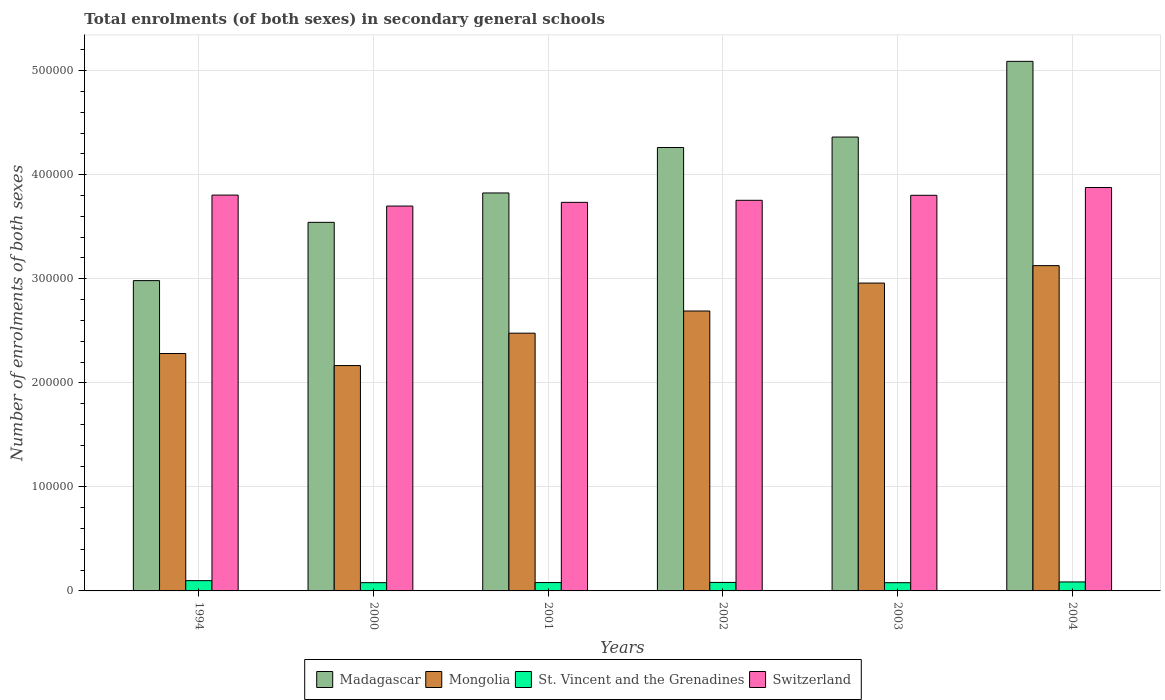Are the number of bars per tick equal to the number of legend labels?
Give a very brief answer. Yes. How many bars are there on the 4th tick from the left?
Offer a very short reply. 4. What is the label of the 1st group of bars from the left?
Keep it short and to the point. 1994. What is the number of enrolments in secondary schools in Mongolia in 1994?
Provide a succinct answer. 2.28e+05. Across all years, what is the maximum number of enrolments in secondary schools in Mongolia?
Offer a very short reply. 3.13e+05. Across all years, what is the minimum number of enrolments in secondary schools in Switzerland?
Provide a succinct answer. 3.70e+05. In which year was the number of enrolments in secondary schools in Mongolia minimum?
Your answer should be compact. 2000. What is the total number of enrolments in secondary schools in St. Vincent and the Grenadines in the graph?
Provide a short and direct response. 5.05e+04. What is the difference between the number of enrolments in secondary schools in Switzerland in 1994 and that in 2000?
Keep it short and to the point. 1.05e+04. What is the difference between the number of enrolments in secondary schools in Switzerland in 2001 and the number of enrolments in secondary schools in St. Vincent and the Grenadines in 2004?
Ensure brevity in your answer.  3.65e+05. What is the average number of enrolments in secondary schools in Madagascar per year?
Make the answer very short. 4.01e+05. In the year 2000, what is the difference between the number of enrolments in secondary schools in Mongolia and number of enrolments in secondary schools in Switzerland?
Ensure brevity in your answer.  -1.53e+05. What is the ratio of the number of enrolments in secondary schools in Madagascar in 1994 to that in 2000?
Provide a succinct answer. 0.84. Is the number of enrolments in secondary schools in Madagascar in 2000 less than that in 2004?
Make the answer very short. Yes. Is the difference between the number of enrolments in secondary schools in Mongolia in 1994 and 2003 greater than the difference between the number of enrolments in secondary schools in Switzerland in 1994 and 2003?
Your answer should be very brief. No. What is the difference between the highest and the second highest number of enrolments in secondary schools in St. Vincent and the Grenadines?
Give a very brief answer. 1241. What is the difference between the highest and the lowest number of enrolments in secondary schools in St. Vincent and the Grenadines?
Your response must be concise. 1961. What does the 4th bar from the left in 2002 represents?
Your answer should be compact. Switzerland. What does the 2nd bar from the right in 1994 represents?
Ensure brevity in your answer.  St. Vincent and the Grenadines. Is it the case that in every year, the sum of the number of enrolments in secondary schools in Switzerland and number of enrolments in secondary schools in Madagascar is greater than the number of enrolments in secondary schools in Mongolia?
Your response must be concise. Yes. How many bars are there?
Make the answer very short. 24. What is the title of the graph?
Give a very brief answer. Total enrolments (of both sexes) in secondary general schools. What is the label or title of the Y-axis?
Ensure brevity in your answer.  Number of enrolments of both sexes. What is the Number of enrolments of both sexes of Madagascar in 1994?
Make the answer very short. 2.98e+05. What is the Number of enrolments of both sexes in Mongolia in 1994?
Provide a succinct answer. 2.28e+05. What is the Number of enrolments of both sexes in St. Vincent and the Grenadines in 1994?
Ensure brevity in your answer.  9870. What is the Number of enrolments of both sexes in Switzerland in 1994?
Your answer should be compact. 3.80e+05. What is the Number of enrolments of both sexes in Madagascar in 2000?
Keep it short and to the point. 3.54e+05. What is the Number of enrolments of both sexes in Mongolia in 2000?
Offer a very short reply. 2.17e+05. What is the Number of enrolments of both sexes of St. Vincent and the Grenadines in 2000?
Give a very brief answer. 7939. What is the Number of enrolments of both sexes in Switzerland in 2000?
Your response must be concise. 3.70e+05. What is the Number of enrolments of both sexes of Madagascar in 2001?
Provide a short and direct response. 3.82e+05. What is the Number of enrolments of both sexes in Mongolia in 2001?
Keep it short and to the point. 2.48e+05. What is the Number of enrolments of both sexes of St. Vincent and the Grenadines in 2001?
Give a very brief answer. 8045. What is the Number of enrolments of both sexes of Switzerland in 2001?
Offer a terse response. 3.73e+05. What is the Number of enrolments of both sexes in Madagascar in 2002?
Keep it short and to the point. 4.26e+05. What is the Number of enrolments of both sexes of Mongolia in 2002?
Your response must be concise. 2.69e+05. What is the Number of enrolments of both sexes of St. Vincent and the Grenadines in 2002?
Make the answer very short. 8157. What is the Number of enrolments of both sexes of Switzerland in 2002?
Offer a very short reply. 3.75e+05. What is the Number of enrolments of both sexes in Madagascar in 2003?
Provide a short and direct response. 4.36e+05. What is the Number of enrolments of both sexes of Mongolia in 2003?
Provide a short and direct response. 2.96e+05. What is the Number of enrolments of both sexes of St. Vincent and the Grenadines in 2003?
Your response must be concise. 7909. What is the Number of enrolments of both sexes of Switzerland in 2003?
Keep it short and to the point. 3.80e+05. What is the Number of enrolments of both sexes in Madagascar in 2004?
Ensure brevity in your answer.  5.09e+05. What is the Number of enrolments of both sexes of Mongolia in 2004?
Provide a succinct answer. 3.13e+05. What is the Number of enrolments of both sexes of St. Vincent and the Grenadines in 2004?
Provide a succinct answer. 8629. What is the Number of enrolments of both sexes of Switzerland in 2004?
Offer a very short reply. 3.88e+05. Across all years, what is the maximum Number of enrolments of both sexes of Madagascar?
Ensure brevity in your answer.  5.09e+05. Across all years, what is the maximum Number of enrolments of both sexes in Mongolia?
Offer a terse response. 3.13e+05. Across all years, what is the maximum Number of enrolments of both sexes in St. Vincent and the Grenadines?
Offer a terse response. 9870. Across all years, what is the maximum Number of enrolments of both sexes in Switzerland?
Your answer should be very brief. 3.88e+05. Across all years, what is the minimum Number of enrolments of both sexes in Madagascar?
Make the answer very short. 2.98e+05. Across all years, what is the minimum Number of enrolments of both sexes in Mongolia?
Offer a very short reply. 2.17e+05. Across all years, what is the minimum Number of enrolments of both sexes of St. Vincent and the Grenadines?
Keep it short and to the point. 7909. Across all years, what is the minimum Number of enrolments of both sexes of Switzerland?
Your response must be concise. 3.70e+05. What is the total Number of enrolments of both sexes of Madagascar in the graph?
Provide a short and direct response. 2.41e+06. What is the total Number of enrolments of both sexes in Mongolia in the graph?
Make the answer very short. 1.57e+06. What is the total Number of enrolments of both sexes of St. Vincent and the Grenadines in the graph?
Your answer should be compact. 5.05e+04. What is the total Number of enrolments of both sexes in Switzerland in the graph?
Offer a very short reply. 2.27e+06. What is the difference between the Number of enrolments of both sexes in Madagascar in 1994 and that in 2000?
Offer a terse response. -5.60e+04. What is the difference between the Number of enrolments of both sexes of Mongolia in 1994 and that in 2000?
Your answer should be compact. 1.16e+04. What is the difference between the Number of enrolments of both sexes in St. Vincent and the Grenadines in 1994 and that in 2000?
Make the answer very short. 1931. What is the difference between the Number of enrolments of both sexes in Switzerland in 1994 and that in 2000?
Ensure brevity in your answer.  1.05e+04. What is the difference between the Number of enrolments of both sexes of Madagascar in 1994 and that in 2001?
Keep it short and to the point. -8.42e+04. What is the difference between the Number of enrolments of both sexes of Mongolia in 1994 and that in 2001?
Offer a terse response. -1.95e+04. What is the difference between the Number of enrolments of both sexes of St. Vincent and the Grenadines in 1994 and that in 2001?
Make the answer very short. 1825. What is the difference between the Number of enrolments of both sexes in Switzerland in 1994 and that in 2001?
Provide a short and direct response. 6978. What is the difference between the Number of enrolments of both sexes of Madagascar in 1994 and that in 2002?
Provide a short and direct response. -1.28e+05. What is the difference between the Number of enrolments of both sexes of Mongolia in 1994 and that in 2002?
Ensure brevity in your answer.  -4.09e+04. What is the difference between the Number of enrolments of both sexes of St. Vincent and the Grenadines in 1994 and that in 2002?
Keep it short and to the point. 1713. What is the difference between the Number of enrolments of both sexes of Switzerland in 1994 and that in 2002?
Your answer should be very brief. 5016. What is the difference between the Number of enrolments of both sexes in Madagascar in 1994 and that in 2003?
Provide a short and direct response. -1.38e+05. What is the difference between the Number of enrolments of both sexes of Mongolia in 1994 and that in 2003?
Provide a short and direct response. -6.77e+04. What is the difference between the Number of enrolments of both sexes of St. Vincent and the Grenadines in 1994 and that in 2003?
Offer a terse response. 1961. What is the difference between the Number of enrolments of both sexes in Switzerland in 1994 and that in 2003?
Offer a very short reply. 216. What is the difference between the Number of enrolments of both sexes of Madagascar in 1994 and that in 2004?
Make the answer very short. -2.11e+05. What is the difference between the Number of enrolments of both sexes in Mongolia in 1994 and that in 2004?
Offer a very short reply. -8.45e+04. What is the difference between the Number of enrolments of both sexes of St. Vincent and the Grenadines in 1994 and that in 2004?
Keep it short and to the point. 1241. What is the difference between the Number of enrolments of both sexes in Switzerland in 1994 and that in 2004?
Your answer should be compact. -7283. What is the difference between the Number of enrolments of both sexes of Madagascar in 2000 and that in 2001?
Your answer should be very brief. -2.82e+04. What is the difference between the Number of enrolments of both sexes in Mongolia in 2000 and that in 2001?
Make the answer very short. -3.11e+04. What is the difference between the Number of enrolments of both sexes in St. Vincent and the Grenadines in 2000 and that in 2001?
Provide a short and direct response. -106. What is the difference between the Number of enrolments of both sexes of Switzerland in 2000 and that in 2001?
Ensure brevity in your answer.  -3567. What is the difference between the Number of enrolments of both sexes of Madagascar in 2000 and that in 2002?
Offer a very short reply. -7.19e+04. What is the difference between the Number of enrolments of both sexes in Mongolia in 2000 and that in 2002?
Keep it short and to the point. -5.24e+04. What is the difference between the Number of enrolments of both sexes of St. Vincent and the Grenadines in 2000 and that in 2002?
Make the answer very short. -218. What is the difference between the Number of enrolments of both sexes of Switzerland in 2000 and that in 2002?
Provide a succinct answer. -5529. What is the difference between the Number of enrolments of both sexes of Madagascar in 2000 and that in 2003?
Keep it short and to the point. -8.20e+04. What is the difference between the Number of enrolments of both sexes of Mongolia in 2000 and that in 2003?
Your response must be concise. -7.93e+04. What is the difference between the Number of enrolments of both sexes of St. Vincent and the Grenadines in 2000 and that in 2003?
Keep it short and to the point. 30. What is the difference between the Number of enrolments of both sexes in Switzerland in 2000 and that in 2003?
Your answer should be very brief. -1.03e+04. What is the difference between the Number of enrolments of both sexes of Madagascar in 2000 and that in 2004?
Provide a short and direct response. -1.55e+05. What is the difference between the Number of enrolments of both sexes in Mongolia in 2000 and that in 2004?
Keep it short and to the point. -9.60e+04. What is the difference between the Number of enrolments of both sexes of St. Vincent and the Grenadines in 2000 and that in 2004?
Ensure brevity in your answer.  -690. What is the difference between the Number of enrolments of both sexes of Switzerland in 2000 and that in 2004?
Make the answer very short. -1.78e+04. What is the difference between the Number of enrolments of both sexes of Madagascar in 2001 and that in 2002?
Your answer should be compact. -4.37e+04. What is the difference between the Number of enrolments of both sexes of Mongolia in 2001 and that in 2002?
Your answer should be very brief. -2.13e+04. What is the difference between the Number of enrolments of both sexes in St. Vincent and the Grenadines in 2001 and that in 2002?
Give a very brief answer. -112. What is the difference between the Number of enrolments of both sexes of Switzerland in 2001 and that in 2002?
Offer a very short reply. -1962. What is the difference between the Number of enrolments of both sexes in Madagascar in 2001 and that in 2003?
Your response must be concise. -5.37e+04. What is the difference between the Number of enrolments of both sexes in Mongolia in 2001 and that in 2003?
Your answer should be very brief. -4.82e+04. What is the difference between the Number of enrolments of both sexes in St. Vincent and the Grenadines in 2001 and that in 2003?
Offer a terse response. 136. What is the difference between the Number of enrolments of both sexes in Switzerland in 2001 and that in 2003?
Your answer should be very brief. -6762. What is the difference between the Number of enrolments of both sexes of Madagascar in 2001 and that in 2004?
Your answer should be compact. -1.26e+05. What is the difference between the Number of enrolments of both sexes in Mongolia in 2001 and that in 2004?
Offer a very short reply. -6.49e+04. What is the difference between the Number of enrolments of both sexes in St. Vincent and the Grenadines in 2001 and that in 2004?
Ensure brevity in your answer.  -584. What is the difference between the Number of enrolments of both sexes of Switzerland in 2001 and that in 2004?
Your answer should be very brief. -1.43e+04. What is the difference between the Number of enrolments of both sexes of Madagascar in 2002 and that in 2003?
Your answer should be very brief. -1.00e+04. What is the difference between the Number of enrolments of both sexes in Mongolia in 2002 and that in 2003?
Give a very brief answer. -2.68e+04. What is the difference between the Number of enrolments of both sexes of St. Vincent and the Grenadines in 2002 and that in 2003?
Offer a very short reply. 248. What is the difference between the Number of enrolments of both sexes of Switzerland in 2002 and that in 2003?
Offer a terse response. -4800. What is the difference between the Number of enrolments of both sexes of Madagascar in 2002 and that in 2004?
Your response must be concise. -8.28e+04. What is the difference between the Number of enrolments of both sexes of Mongolia in 2002 and that in 2004?
Provide a short and direct response. -4.36e+04. What is the difference between the Number of enrolments of both sexes of St. Vincent and the Grenadines in 2002 and that in 2004?
Your answer should be very brief. -472. What is the difference between the Number of enrolments of both sexes of Switzerland in 2002 and that in 2004?
Provide a succinct answer. -1.23e+04. What is the difference between the Number of enrolments of both sexes of Madagascar in 2003 and that in 2004?
Your answer should be compact. -7.28e+04. What is the difference between the Number of enrolments of both sexes of Mongolia in 2003 and that in 2004?
Offer a terse response. -1.68e+04. What is the difference between the Number of enrolments of both sexes of St. Vincent and the Grenadines in 2003 and that in 2004?
Offer a terse response. -720. What is the difference between the Number of enrolments of both sexes of Switzerland in 2003 and that in 2004?
Offer a very short reply. -7499. What is the difference between the Number of enrolments of both sexes of Madagascar in 1994 and the Number of enrolments of both sexes of Mongolia in 2000?
Your response must be concise. 8.16e+04. What is the difference between the Number of enrolments of both sexes of Madagascar in 1994 and the Number of enrolments of both sexes of St. Vincent and the Grenadines in 2000?
Offer a terse response. 2.90e+05. What is the difference between the Number of enrolments of both sexes in Madagascar in 1994 and the Number of enrolments of both sexes in Switzerland in 2000?
Ensure brevity in your answer.  -7.17e+04. What is the difference between the Number of enrolments of both sexes of Mongolia in 1994 and the Number of enrolments of both sexes of St. Vincent and the Grenadines in 2000?
Your answer should be compact. 2.20e+05. What is the difference between the Number of enrolments of both sexes in Mongolia in 1994 and the Number of enrolments of both sexes in Switzerland in 2000?
Provide a succinct answer. -1.42e+05. What is the difference between the Number of enrolments of both sexes in St. Vincent and the Grenadines in 1994 and the Number of enrolments of both sexes in Switzerland in 2000?
Offer a very short reply. -3.60e+05. What is the difference between the Number of enrolments of both sexes in Madagascar in 1994 and the Number of enrolments of both sexes in Mongolia in 2001?
Your response must be concise. 5.05e+04. What is the difference between the Number of enrolments of both sexes of Madagascar in 1994 and the Number of enrolments of both sexes of St. Vincent and the Grenadines in 2001?
Keep it short and to the point. 2.90e+05. What is the difference between the Number of enrolments of both sexes in Madagascar in 1994 and the Number of enrolments of both sexes in Switzerland in 2001?
Offer a very short reply. -7.52e+04. What is the difference between the Number of enrolments of both sexes of Mongolia in 1994 and the Number of enrolments of both sexes of St. Vincent and the Grenadines in 2001?
Provide a short and direct response. 2.20e+05. What is the difference between the Number of enrolments of both sexes in Mongolia in 1994 and the Number of enrolments of both sexes in Switzerland in 2001?
Offer a terse response. -1.45e+05. What is the difference between the Number of enrolments of both sexes in St. Vincent and the Grenadines in 1994 and the Number of enrolments of both sexes in Switzerland in 2001?
Give a very brief answer. -3.64e+05. What is the difference between the Number of enrolments of both sexes in Madagascar in 1994 and the Number of enrolments of both sexes in Mongolia in 2002?
Give a very brief answer. 2.92e+04. What is the difference between the Number of enrolments of both sexes of Madagascar in 1994 and the Number of enrolments of both sexes of St. Vincent and the Grenadines in 2002?
Provide a succinct answer. 2.90e+05. What is the difference between the Number of enrolments of both sexes of Madagascar in 1994 and the Number of enrolments of both sexes of Switzerland in 2002?
Make the answer very short. -7.72e+04. What is the difference between the Number of enrolments of both sexes in Mongolia in 1994 and the Number of enrolments of both sexes in St. Vincent and the Grenadines in 2002?
Your response must be concise. 2.20e+05. What is the difference between the Number of enrolments of both sexes in Mongolia in 1994 and the Number of enrolments of both sexes in Switzerland in 2002?
Give a very brief answer. -1.47e+05. What is the difference between the Number of enrolments of both sexes of St. Vincent and the Grenadines in 1994 and the Number of enrolments of both sexes of Switzerland in 2002?
Your answer should be very brief. -3.66e+05. What is the difference between the Number of enrolments of both sexes in Madagascar in 1994 and the Number of enrolments of both sexes in Mongolia in 2003?
Your answer should be very brief. 2367. What is the difference between the Number of enrolments of both sexes in Madagascar in 1994 and the Number of enrolments of both sexes in St. Vincent and the Grenadines in 2003?
Offer a terse response. 2.90e+05. What is the difference between the Number of enrolments of both sexes in Madagascar in 1994 and the Number of enrolments of both sexes in Switzerland in 2003?
Give a very brief answer. -8.20e+04. What is the difference between the Number of enrolments of both sexes in Mongolia in 1994 and the Number of enrolments of both sexes in St. Vincent and the Grenadines in 2003?
Your response must be concise. 2.20e+05. What is the difference between the Number of enrolments of both sexes in Mongolia in 1994 and the Number of enrolments of both sexes in Switzerland in 2003?
Offer a terse response. -1.52e+05. What is the difference between the Number of enrolments of both sexes of St. Vincent and the Grenadines in 1994 and the Number of enrolments of both sexes of Switzerland in 2003?
Provide a short and direct response. -3.70e+05. What is the difference between the Number of enrolments of both sexes in Madagascar in 1994 and the Number of enrolments of both sexes in Mongolia in 2004?
Make the answer very short. -1.44e+04. What is the difference between the Number of enrolments of both sexes in Madagascar in 1994 and the Number of enrolments of both sexes in St. Vincent and the Grenadines in 2004?
Offer a very short reply. 2.90e+05. What is the difference between the Number of enrolments of both sexes in Madagascar in 1994 and the Number of enrolments of both sexes in Switzerland in 2004?
Your answer should be very brief. -8.95e+04. What is the difference between the Number of enrolments of both sexes of Mongolia in 1994 and the Number of enrolments of both sexes of St. Vincent and the Grenadines in 2004?
Make the answer very short. 2.20e+05. What is the difference between the Number of enrolments of both sexes in Mongolia in 1994 and the Number of enrolments of both sexes in Switzerland in 2004?
Make the answer very short. -1.60e+05. What is the difference between the Number of enrolments of both sexes of St. Vincent and the Grenadines in 1994 and the Number of enrolments of both sexes of Switzerland in 2004?
Offer a very short reply. -3.78e+05. What is the difference between the Number of enrolments of both sexes of Madagascar in 2000 and the Number of enrolments of both sexes of Mongolia in 2001?
Give a very brief answer. 1.07e+05. What is the difference between the Number of enrolments of both sexes of Madagascar in 2000 and the Number of enrolments of both sexes of St. Vincent and the Grenadines in 2001?
Offer a terse response. 3.46e+05. What is the difference between the Number of enrolments of both sexes in Madagascar in 2000 and the Number of enrolments of both sexes in Switzerland in 2001?
Offer a very short reply. -1.92e+04. What is the difference between the Number of enrolments of both sexes in Mongolia in 2000 and the Number of enrolments of both sexes in St. Vincent and the Grenadines in 2001?
Provide a succinct answer. 2.09e+05. What is the difference between the Number of enrolments of both sexes in Mongolia in 2000 and the Number of enrolments of both sexes in Switzerland in 2001?
Provide a succinct answer. -1.57e+05. What is the difference between the Number of enrolments of both sexes of St. Vincent and the Grenadines in 2000 and the Number of enrolments of both sexes of Switzerland in 2001?
Keep it short and to the point. -3.66e+05. What is the difference between the Number of enrolments of both sexes of Madagascar in 2000 and the Number of enrolments of both sexes of Mongolia in 2002?
Keep it short and to the point. 8.52e+04. What is the difference between the Number of enrolments of both sexes of Madagascar in 2000 and the Number of enrolments of both sexes of St. Vincent and the Grenadines in 2002?
Your answer should be very brief. 3.46e+05. What is the difference between the Number of enrolments of both sexes in Madagascar in 2000 and the Number of enrolments of both sexes in Switzerland in 2002?
Provide a short and direct response. -2.12e+04. What is the difference between the Number of enrolments of both sexes in Mongolia in 2000 and the Number of enrolments of both sexes in St. Vincent and the Grenadines in 2002?
Your answer should be compact. 2.08e+05. What is the difference between the Number of enrolments of both sexes in Mongolia in 2000 and the Number of enrolments of both sexes in Switzerland in 2002?
Offer a very short reply. -1.59e+05. What is the difference between the Number of enrolments of both sexes in St. Vincent and the Grenadines in 2000 and the Number of enrolments of both sexes in Switzerland in 2002?
Offer a very short reply. -3.67e+05. What is the difference between the Number of enrolments of both sexes of Madagascar in 2000 and the Number of enrolments of both sexes of Mongolia in 2003?
Your answer should be compact. 5.84e+04. What is the difference between the Number of enrolments of both sexes in Madagascar in 2000 and the Number of enrolments of both sexes in St. Vincent and the Grenadines in 2003?
Your response must be concise. 3.46e+05. What is the difference between the Number of enrolments of both sexes of Madagascar in 2000 and the Number of enrolments of both sexes of Switzerland in 2003?
Give a very brief answer. -2.60e+04. What is the difference between the Number of enrolments of both sexes in Mongolia in 2000 and the Number of enrolments of both sexes in St. Vincent and the Grenadines in 2003?
Your answer should be very brief. 2.09e+05. What is the difference between the Number of enrolments of both sexes of Mongolia in 2000 and the Number of enrolments of both sexes of Switzerland in 2003?
Your answer should be very brief. -1.64e+05. What is the difference between the Number of enrolments of both sexes of St. Vincent and the Grenadines in 2000 and the Number of enrolments of both sexes of Switzerland in 2003?
Give a very brief answer. -3.72e+05. What is the difference between the Number of enrolments of both sexes in Madagascar in 2000 and the Number of enrolments of both sexes in Mongolia in 2004?
Your response must be concise. 4.16e+04. What is the difference between the Number of enrolments of both sexes of Madagascar in 2000 and the Number of enrolments of both sexes of St. Vincent and the Grenadines in 2004?
Your answer should be very brief. 3.46e+05. What is the difference between the Number of enrolments of both sexes in Madagascar in 2000 and the Number of enrolments of both sexes in Switzerland in 2004?
Your answer should be compact. -3.35e+04. What is the difference between the Number of enrolments of both sexes in Mongolia in 2000 and the Number of enrolments of both sexes in St. Vincent and the Grenadines in 2004?
Keep it short and to the point. 2.08e+05. What is the difference between the Number of enrolments of both sexes in Mongolia in 2000 and the Number of enrolments of both sexes in Switzerland in 2004?
Your response must be concise. -1.71e+05. What is the difference between the Number of enrolments of both sexes in St. Vincent and the Grenadines in 2000 and the Number of enrolments of both sexes in Switzerland in 2004?
Your answer should be compact. -3.80e+05. What is the difference between the Number of enrolments of both sexes of Madagascar in 2001 and the Number of enrolments of both sexes of Mongolia in 2002?
Ensure brevity in your answer.  1.13e+05. What is the difference between the Number of enrolments of both sexes of Madagascar in 2001 and the Number of enrolments of both sexes of St. Vincent and the Grenadines in 2002?
Give a very brief answer. 3.74e+05. What is the difference between the Number of enrolments of both sexes in Madagascar in 2001 and the Number of enrolments of both sexes in Switzerland in 2002?
Your response must be concise. 7050. What is the difference between the Number of enrolments of both sexes of Mongolia in 2001 and the Number of enrolments of both sexes of St. Vincent and the Grenadines in 2002?
Provide a succinct answer. 2.40e+05. What is the difference between the Number of enrolments of both sexes in Mongolia in 2001 and the Number of enrolments of both sexes in Switzerland in 2002?
Provide a succinct answer. -1.28e+05. What is the difference between the Number of enrolments of both sexes in St. Vincent and the Grenadines in 2001 and the Number of enrolments of both sexes in Switzerland in 2002?
Keep it short and to the point. -3.67e+05. What is the difference between the Number of enrolments of both sexes of Madagascar in 2001 and the Number of enrolments of both sexes of Mongolia in 2003?
Your response must be concise. 8.66e+04. What is the difference between the Number of enrolments of both sexes of Madagascar in 2001 and the Number of enrolments of both sexes of St. Vincent and the Grenadines in 2003?
Offer a very short reply. 3.75e+05. What is the difference between the Number of enrolments of both sexes of Madagascar in 2001 and the Number of enrolments of both sexes of Switzerland in 2003?
Your response must be concise. 2250. What is the difference between the Number of enrolments of both sexes of Mongolia in 2001 and the Number of enrolments of both sexes of St. Vincent and the Grenadines in 2003?
Provide a short and direct response. 2.40e+05. What is the difference between the Number of enrolments of both sexes in Mongolia in 2001 and the Number of enrolments of both sexes in Switzerland in 2003?
Make the answer very short. -1.33e+05. What is the difference between the Number of enrolments of both sexes of St. Vincent and the Grenadines in 2001 and the Number of enrolments of both sexes of Switzerland in 2003?
Make the answer very short. -3.72e+05. What is the difference between the Number of enrolments of both sexes of Madagascar in 2001 and the Number of enrolments of both sexes of Mongolia in 2004?
Provide a succinct answer. 6.98e+04. What is the difference between the Number of enrolments of both sexes of Madagascar in 2001 and the Number of enrolments of both sexes of St. Vincent and the Grenadines in 2004?
Offer a terse response. 3.74e+05. What is the difference between the Number of enrolments of both sexes in Madagascar in 2001 and the Number of enrolments of both sexes in Switzerland in 2004?
Offer a terse response. -5249. What is the difference between the Number of enrolments of both sexes of Mongolia in 2001 and the Number of enrolments of both sexes of St. Vincent and the Grenadines in 2004?
Make the answer very short. 2.39e+05. What is the difference between the Number of enrolments of both sexes in Mongolia in 2001 and the Number of enrolments of both sexes in Switzerland in 2004?
Provide a succinct answer. -1.40e+05. What is the difference between the Number of enrolments of both sexes of St. Vincent and the Grenadines in 2001 and the Number of enrolments of both sexes of Switzerland in 2004?
Make the answer very short. -3.80e+05. What is the difference between the Number of enrolments of both sexes in Madagascar in 2002 and the Number of enrolments of both sexes in Mongolia in 2003?
Provide a short and direct response. 1.30e+05. What is the difference between the Number of enrolments of both sexes of Madagascar in 2002 and the Number of enrolments of both sexes of St. Vincent and the Grenadines in 2003?
Your answer should be compact. 4.18e+05. What is the difference between the Number of enrolments of both sexes of Madagascar in 2002 and the Number of enrolments of both sexes of Switzerland in 2003?
Your answer should be very brief. 4.59e+04. What is the difference between the Number of enrolments of both sexes of Mongolia in 2002 and the Number of enrolments of both sexes of St. Vincent and the Grenadines in 2003?
Keep it short and to the point. 2.61e+05. What is the difference between the Number of enrolments of both sexes in Mongolia in 2002 and the Number of enrolments of both sexes in Switzerland in 2003?
Ensure brevity in your answer.  -1.11e+05. What is the difference between the Number of enrolments of both sexes in St. Vincent and the Grenadines in 2002 and the Number of enrolments of both sexes in Switzerland in 2003?
Your response must be concise. -3.72e+05. What is the difference between the Number of enrolments of both sexes in Madagascar in 2002 and the Number of enrolments of both sexes in Mongolia in 2004?
Your response must be concise. 1.14e+05. What is the difference between the Number of enrolments of both sexes of Madagascar in 2002 and the Number of enrolments of both sexes of St. Vincent and the Grenadines in 2004?
Make the answer very short. 4.18e+05. What is the difference between the Number of enrolments of both sexes in Madagascar in 2002 and the Number of enrolments of both sexes in Switzerland in 2004?
Your answer should be very brief. 3.84e+04. What is the difference between the Number of enrolments of both sexes of Mongolia in 2002 and the Number of enrolments of both sexes of St. Vincent and the Grenadines in 2004?
Provide a succinct answer. 2.60e+05. What is the difference between the Number of enrolments of both sexes in Mongolia in 2002 and the Number of enrolments of both sexes in Switzerland in 2004?
Provide a succinct answer. -1.19e+05. What is the difference between the Number of enrolments of both sexes of St. Vincent and the Grenadines in 2002 and the Number of enrolments of both sexes of Switzerland in 2004?
Your answer should be very brief. -3.80e+05. What is the difference between the Number of enrolments of both sexes in Madagascar in 2003 and the Number of enrolments of both sexes in Mongolia in 2004?
Make the answer very short. 1.24e+05. What is the difference between the Number of enrolments of both sexes in Madagascar in 2003 and the Number of enrolments of both sexes in St. Vincent and the Grenadines in 2004?
Ensure brevity in your answer.  4.28e+05. What is the difference between the Number of enrolments of both sexes of Madagascar in 2003 and the Number of enrolments of both sexes of Switzerland in 2004?
Ensure brevity in your answer.  4.85e+04. What is the difference between the Number of enrolments of both sexes of Mongolia in 2003 and the Number of enrolments of both sexes of St. Vincent and the Grenadines in 2004?
Ensure brevity in your answer.  2.87e+05. What is the difference between the Number of enrolments of both sexes in Mongolia in 2003 and the Number of enrolments of both sexes in Switzerland in 2004?
Give a very brief answer. -9.18e+04. What is the difference between the Number of enrolments of both sexes of St. Vincent and the Grenadines in 2003 and the Number of enrolments of both sexes of Switzerland in 2004?
Make the answer very short. -3.80e+05. What is the average Number of enrolments of both sexes in Madagascar per year?
Your response must be concise. 4.01e+05. What is the average Number of enrolments of both sexes in Mongolia per year?
Your answer should be compact. 2.62e+05. What is the average Number of enrolments of both sexes in St. Vincent and the Grenadines per year?
Provide a short and direct response. 8424.83. What is the average Number of enrolments of both sexes of Switzerland per year?
Ensure brevity in your answer.  3.78e+05. In the year 1994, what is the difference between the Number of enrolments of both sexes of Madagascar and Number of enrolments of both sexes of Mongolia?
Give a very brief answer. 7.01e+04. In the year 1994, what is the difference between the Number of enrolments of both sexes of Madagascar and Number of enrolments of both sexes of St. Vincent and the Grenadines?
Provide a succinct answer. 2.88e+05. In the year 1994, what is the difference between the Number of enrolments of both sexes of Madagascar and Number of enrolments of both sexes of Switzerland?
Your answer should be compact. -8.22e+04. In the year 1994, what is the difference between the Number of enrolments of both sexes of Mongolia and Number of enrolments of both sexes of St. Vincent and the Grenadines?
Make the answer very short. 2.18e+05. In the year 1994, what is the difference between the Number of enrolments of both sexes in Mongolia and Number of enrolments of both sexes in Switzerland?
Make the answer very short. -1.52e+05. In the year 1994, what is the difference between the Number of enrolments of both sexes in St. Vincent and the Grenadines and Number of enrolments of both sexes in Switzerland?
Your answer should be compact. -3.71e+05. In the year 2000, what is the difference between the Number of enrolments of both sexes of Madagascar and Number of enrolments of both sexes of Mongolia?
Your answer should be very brief. 1.38e+05. In the year 2000, what is the difference between the Number of enrolments of both sexes in Madagascar and Number of enrolments of both sexes in St. Vincent and the Grenadines?
Give a very brief answer. 3.46e+05. In the year 2000, what is the difference between the Number of enrolments of both sexes of Madagascar and Number of enrolments of both sexes of Switzerland?
Offer a very short reply. -1.56e+04. In the year 2000, what is the difference between the Number of enrolments of both sexes of Mongolia and Number of enrolments of both sexes of St. Vincent and the Grenadines?
Provide a short and direct response. 2.09e+05. In the year 2000, what is the difference between the Number of enrolments of both sexes in Mongolia and Number of enrolments of both sexes in Switzerland?
Offer a terse response. -1.53e+05. In the year 2000, what is the difference between the Number of enrolments of both sexes in St. Vincent and the Grenadines and Number of enrolments of both sexes in Switzerland?
Give a very brief answer. -3.62e+05. In the year 2001, what is the difference between the Number of enrolments of both sexes in Madagascar and Number of enrolments of both sexes in Mongolia?
Your answer should be compact. 1.35e+05. In the year 2001, what is the difference between the Number of enrolments of both sexes of Madagascar and Number of enrolments of both sexes of St. Vincent and the Grenadines?
Provide a succinct answer. 3.74e+05. In the year 2001, what is the difference between the Number of enrolments of both sexes in Madagascar and Number of enrolments of both sexes in Switzerland?
Keep it short and to the point. 9012. In the year 2001, what is the difference between the Number of enrolments of both sexes in Mongolia and Number of enrolments of both sexes in St. Vincent and the Grenadines?
Provide a succinct answer. 2.40e+05. In the year 2001, what is the difference between the Number of enrolments of both sexes in Mongolia and Number of enrolments of both sexes in Switzerland?
Offer a terse response. -1.26e+05. In the year 2001, what is the difference between the Number of enrolments of both sexes in St. Vincent and the Grenadines and Number of enrolments of both sexes in Switzerland?
Provide a short and direct response. -3.65e+05. In the year 2002, what is the difference between the Number of enrolments of both sexes in Madagascar and Number of enrolments of both sexes in Mongolia?
Keep it short and to the point. 1.57e+05. In the year 2002, what is the difference between the Number of enrolments of both sexes in Madagascar and Number of enrolments of both sexes in St. Vincent and the Grenadines?
Make the answer very short. 4.18e+05. In the year 2002, what is the difference between the Number of enrolments of both sexes in Madagascar and Number of enrolments of both sexes in Switzerland?
Your answer should be compact. 5.07e+04. In the year 2002, what is the difference between the Number of enrolments of both sexes in Mongolia and Number of enrolments of both sexes in St. Vincent and the Grenadines?
Ensure brevity in your answer.  2.61e+05. In the year 2002, what is the difference between the Number of enrolments of both sexes in Mongolia and Number of enrolments of both sexes in Switzerland?
Give a very brief answer. -1.06e+05. In the year 2002, what is the difference between the Number of enrolments of both sexes of St. Vincent and the Grenadines and Number of enrolments of both sexes of Switzerland?
Make the answer very short. -3.67e+05. In the year 2003, what is the difference between the Number of enrolments of both sexes of Madagascar and Number of enrolments of both sexes of Mongolia?
Offer a terse response. 1.40e+05. In the year 2003, what is the difference between the Number of enrolments of both sexes of Madagascar and Number of enrolments of both sexes of St. Vincent and the Grenadines?
Give a very brief answer. 4.28e+05. In the year 2003, what is the difference between the Number of enrolments of both sexes of Madagascar and Number of enrolments of both sexes of Switzerland?
Make the answer very short. 5.60e+04. In the year 2003, what is the difference between the Number of enrolments of both sexes in Mongolia and Number of enrolments of both sexes in St. Vincent and the Grenadines?
Ensure brevity in your answer.  2.88e+05. In the year 2003, what is the difference between the Number of enrolments of both sexes in Mongolia and Number of enrolments of both sexes in Switzerland?
Provide a short and direct response. -8.44e+04. In the year 2003, what is the difference between the Number of enrolments of both sexes of St. Vincent and the Grenadines and Number of enrolments of both sexes of Switzerland?
Your answer should be compact. -3.72e+05. In the year 2004, what is the difference between the Number of enrolments of both sexes in Madagascar and Number of enrolments of both sexes in Mongolia?
Make the answer very short. 1.96e+05. In the year 2004, what is the difference between the Number of enrolments of both sexes of Madagascar and Number of enrolments of both sexes of St. Vincent and the Grenadines?
Offer a very short reply. 5.00e+05. In the year 2004, what is the difference between the Number of enrolments of both sexes of Madagascar and Number of enrolments of both sexes of Switzerland?
Provide a succinct answer. 1.21e+05. In the year 2004, what is the difference between the Number of enrolments of both sexes of Mongolia and Number of enrolments of both sexes of St. Vincent and the Grenadines?
Your response must be concise. 3.04e+05. In the year 2004, what is the difference between the Number of enrolments of both sexes in Mongolia and Number of enrolments of both sexes in Switzerland?
Your answer should be compact. -7.51e+04. In the year 2004, what is the difference between the Number of enrolments of both sexes in St. Vincent and the Grenadines and Number of enrolments of both sexes in Switzerland?
Your answer should be very brief. -3.79e+05. What is the ratio of the Number of enrolments of both sexes in Madagascar in 1994 to that in 2000?
Give a very brief answer. 0.84. What is the ratio of the Number of enrolments of both sexes of Mongolia in 1994 to that in 2000?
Provide a succinct answer. 1.05. What is the ratio of the Number of enrolments of both sexes of St. Vincent and the Grenadines in 1994 to that in 2000?
Your response must be concise. 1.24. What is the ratio of the Number of enrolments of both sexes of Switzerland in 1994 to that in 2000?
Offer a very short reply. 1.03. What is the ratio of the Number of enrolments of both sexes of Madagascar in 1994 to that in 2001?
Ensure brevity in your answer.  0.78. What is the ratio of the Number of enrolments of both sexes of Mongolia in 1994 to that in 2001?
Your response must be concise. 0.92. What is the ratio of the Number of enrolments of both sexes in St. Vincent and the Grenadines in 1994 to that in 2001?
Make the answer very short. 1.23. What is the ratio of the Number of enrolments of both sexes in Switzerland in 1994 to that in 2001?
Offer a terse response. 1.02. What is the ratio of the Number of enrolments of both sexes of Madagascar in 1994 to that in 2002?
Your answer should be very brief. 0.7. What is the ratio of the Number of enrolments of both sexes of Mongolia in 1994 to that in 2002?
Offer a terse response. 0.85. What is the ratio of the Number of enrolments of both sexes in St. Vincent and the Grenadines in 1994 to that in 2002?
Keep it short and to the point. 1.21. What is the ratio of the Number of enrolments of both sexes of Switzerland in 1994 to that in 2002?
Offer a very short reply. 1.01. What is the ratio of the Number of enrolments of both sexes of Madagascar in 1994 to that in 2003?
Provide a short and direct response. 0.68. What is the ratio of the Number of enrolments of both sexes in Mongolia in 1994 to that in 2003?
Your answer should be compact. 0.77. What is the ratio of the Number of enrolments of both sexes of St. Vincent and the Grenadines in 1994 to that in 2003?
Keep it short and to the point. 1.25. What is the ratio of the Number of enrolments of both sexes in Switzerland in 1994 to that in 2003?
Your answer should be very brief. 1. What is the ratio of the Number of enrolments of both sexes in Madagascar in 1994 to that in 2004?
Offer a very short reply. 0.59. What is the ratio of the Number of enrolments of both sexes in Mongolia in 1994 to that in 2004?
Your answer should be very brief. 0.73. What is the ratio of the Number of enrolments of both sexes in St. Vincent and the Grenadines in 1994 to that in 2004?
Provide a succinct answer. 1.14. What is the ratio of the Number of enrolments of both sexes of Switzerland in 1994 to that in 2004?
Your response must be concise. 0.98. What is the ratio of the Number of enrolments of both sexes in Madagascar in 2000 to that in 2001?
Provide a succinct answer. 0.93. What is the ratio of the Number of enrolments of both sexes in Mongolia in 2000 to that in 2001?
Ensure brevity in your answer.  0.87. What is the ratio of the Number of enrolments of both sexes of St. Vincent and the Grenadines in 2000 to that in 2001?
Your answer should be compact. 0.99. What is the ratio of the Number of enrolments of both sexes in Madagascar in 2000 to that in 2002?
Make the answer very short. 0.83. What is the ratio of the Number of enrolments of both sexes of Mongolia in 2000 to that in 2002?
Provide a short and direct response. 0.81. What is the ratio of the Number of enrolments of both sexes of St. Vincent and the Grenadines in 2000 to that in 2002?
Offer a very short reply. 0.97. What is the ratio of the Number of enrolments of both sexes of Madagascar in 2000 to that in 2003?
Offer a very short reply. 0.81. What is the ratio of the Number of enrolments of both sexes in Mongolia in 2000 to that in 2003?
Keep it short and to the point. 0.73. What is the ratio of the Number of enrolments of both sexes of St. Vincent and the Grenadines in 2000 to that in 2003?
Offer a terse response. 1. What is the ratio of the Number of enrolments of both sexes of Switzerland in 2000 to that in 2003?
Your answer should be very brief. 0.97. What is the ratio of the Number of enrolments of both sexes of Madagascar in 2000 to that in 2004?
Give a very brief answer. 0.7. What is the ratio of the Number of enrolments of both sexes in Mongolia in 2000 to that in 2004?
Your answer should be very brief. 0.69. What is the ratio of the Number of enrolments of both sexes in St. Vincent and the Grenadines in 2000 to that in 2004?
Ensure brevity in your answer.  0.92. What is the ratio of the Number of enrolments of both sexes in Switzerland in 2000 to that in 2004?
Your response must be concise. 0.95. What is the ratio of the Number of enrolments of both sexes of Madagascar in 2001 to that in 2002?
Make the answer very short. 0.9. What is the ratio of the Number of enrolments of both sexes in Mongolia in 2001 to that in 2002?
Provide a short and direct response. 0.92. What is the ratio of the Number of enrolments of both sexes of St. Vincent and the Grenadines in 2001 to that in 2002?
Provide a short and direct response. 0.99. What is the ratio of the Number of enrolments of both sexes of Madagascar in 2001 to that in 2003?
Make the answer very short. 0.88. What is the ratio of the Number of enrolments of both sexes in Mongolia in 2001 to that in 2003?
Provide a short and direct response. 0.84. What is the ratio of the Number of enrolments of both sexes of St. Vincent and the Grenadines in 2001 to that in 2003?
Offer a very short reply. 1.02. What is the ratio of the Number of enrolments of both sexes of Switzerland in 2001 to that in 2003?
Offer a very short reply. 0.98. What is the ratio of the Number of enrolments of both sexes in Madagascar in 2001 to that in 2004?
Provide a short and direct response. 0.75. What is the ratio of the Number of enrolments of both sexes in Mongolia in 2001 to that in 2004?
Provide a short and direct response. 0.79. What is the ratio of the Number of enrolments of both sexes of St. Vincent and the Grenadines in 2001 to that in 2004?
Your answer should be compact. 0.93. What is the ratio of the Number of enrolments of both sexes of Switzerland in 2001 to that in 2004?
Your answer should be very brief. 0.96. What is the ratio of the Number of enrolments of both sexes in Mongolia in 2002 to that in 2003?
Your answer should be very brief. 0.91. What is the ratio of the Number of enrolments of both sexes in St. Vincent and the Grenadines in 2002 to that in 2003?
Your answer should be very brief. 1.03. What is the ratio of the Number of enrolments of both sexes in Switzerland in 2002 to that in 2003?
Keep it short and to the point. 0.99. What is the ratio of the Number of enrolments of both sexes of Madagascar in 2002 to that in 2004?
Keep it short and to the point. 0.84. What is the ratio of the Number of enrolments of both sexes in Mongolia in 2002 to that in 2004?
Give a very brief answer. 0.86. What is the ratio of the Number of enrolments of both sexes in St. Vincent and the Grenadines in 2002 to that in 2004?
Your answer should be very brief. 0.95. What is the ratio of the Number of enrolments of both sexes in Switzerland in 2002 to that in 2004?
Make the answer very short. 0.97. What is the ratio of the Number of enrolments of both sexes of Madagascar in 2003 to that in 2004?
Keep it short and to the point. 0.86. What is the ratio of the Number of enrolments of both sexes in Mongolia in 2003 to that in 2004?
Offer a terse response. 0.95. What is the ratio of the Number of enrolments of both sexes in St. Vincent and the Grenadines in 2003 to that in 2004?
Keep it short and to the point. 0.92. What is the ratio of the Number of enrolments of both sexes in Switzerland in 2003 to that in 2004?
Your response must be concise. 0.98. What is the difference between the highest and the second highest Number of enrolments of both sexes of Madagascar?
Offer a very short reply. 7.28e+04. What is the difference between the highest and the second highest Number of enrolments of both sexes in Mongolia?
Ensure brevity in your answer.  1.68e+04. What is the difference between the highest and the second highest Number of enrolments of both sexes of St. Vincent and the Grenadines?
Offer a very short reply. 1241. What is the difference between the highest and the second highest Number of enrolments of both sexes of Switzerland?
Your response must be concise. 7283. What is the difference between the highest and the lowest Number of enrolments of both sexes of Madagascar?
Offer a terse response. 2.11e+05. What is the difference between the highest and the lowest Number of enrolments of both sexes of Mongolia?
Keep it short and to the point. 9.60e+04. What is the difference between the highest and the lowest Number of enrolments of both sexes in St. Vincent and the Grenadines?
Your response must be concise. 1961. What is the difference between the highest and the lowest Number of enrolments of both sexes in Switzerland?
Make the answer very short. 1.78e+04. 